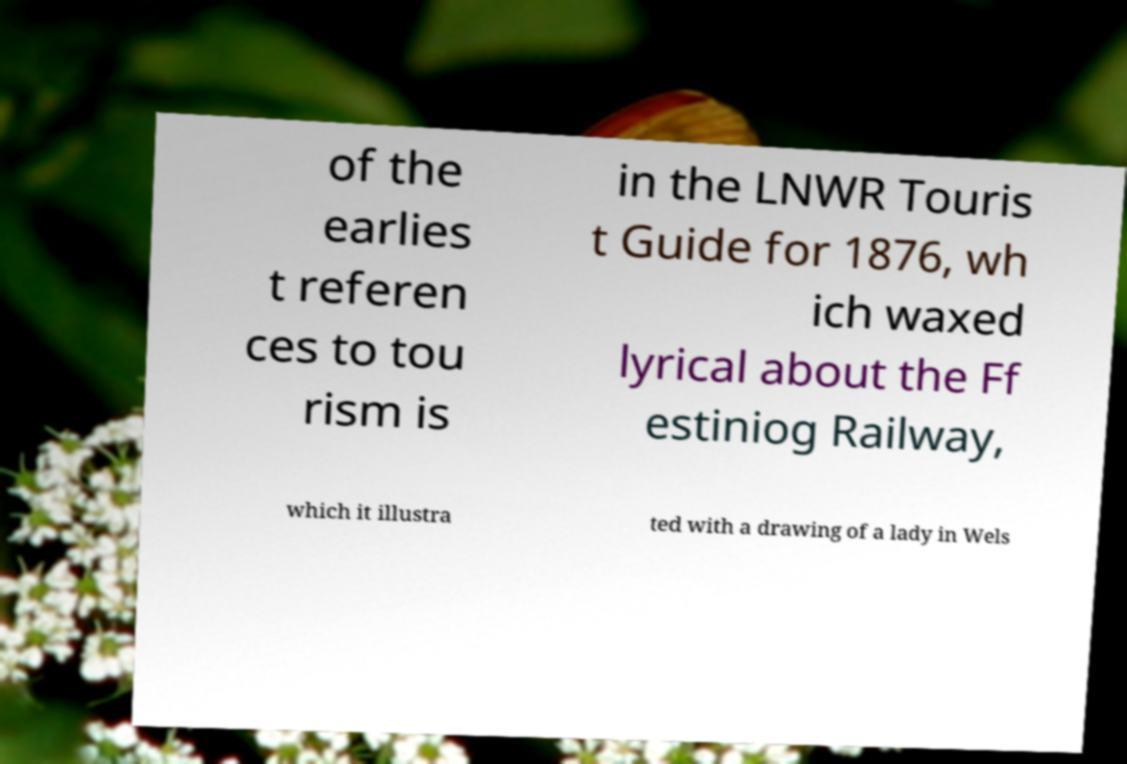Please read and relay the text visible in this image. What does it say? of the earlies t referen ces to tou rism is in the LNWR Touris t Guide for 1876, wh ich waxed lyrical about the Ff estiniog Railway, which it illustra ted with a drawing of a lady in Wels 